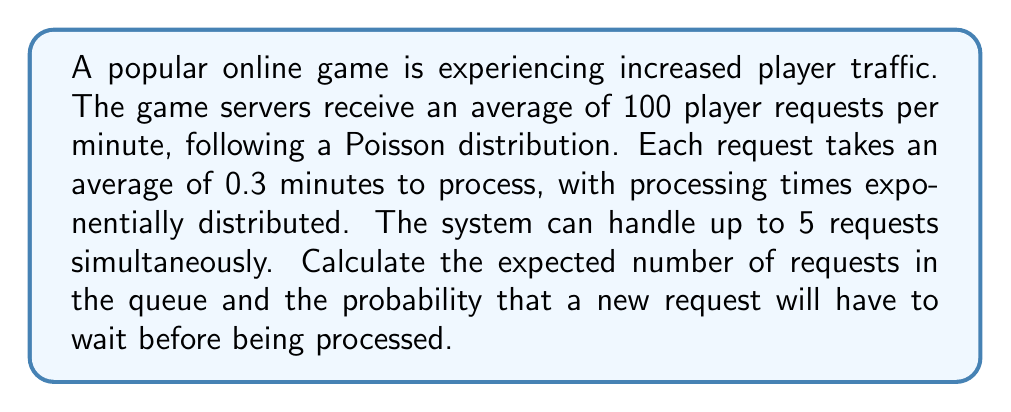Show me your answer to this math problem. To solve this problem, we'll use the M/M/c queueing model, where M/M indicates Markovian arrival and service times, and c is the number of servers (in this case, c = 5).

Step 1: Calculate the utilization factor ρ
λ = arrival rate = 100 requests/minute
μ = service rate = 1/0.3 = 3.33 requests/minute
c = number of servers = 5

$$ \rho = \frac{\lambda}{c\mu} = \frac{100}{5 \cdot 3.33} \approx 6 $$

Step 2: Calculate P0, the probability of an empty system
$$ P_0 = \left[\sum_{n=0}^{c-1}\frac{(c\rho)^n}{n!} + \frac{(c\rho)^c}{c!(1-\rho)}\right]^{-1} $$

Using a calculator or computer, we find P0 ≈ 0.0000767

Step 3: Calculate Lq, the expected number of requests in the queue
$$ L_q = \frac{P_0(c\rho)^c\rho}{c!(1-\rho)^2} $$

Substituting the values:
$$ L_q = \frac{0.0000767 \cdot (5 \cdot 6)^5 \cdot 6}{5!(1-6)^2} \approx 180.56 $$

Step 4: Calculate the probability that a new request will have to wait
This is equivalent to the probability that all servers are busy:
$$ P(\text{wait}) = \frac{P_0(c\rho)^c}{c!(1-\rho)} $$

Substituting the values:
$$ P(\text{wait}) = \frac{0.0000767 \cdot (5 \cdot 6)^5}{5!(1-6)} \approx 0.9997 $$
Answer: 180.56 requests in queue; 0.9997 probability of waiting 